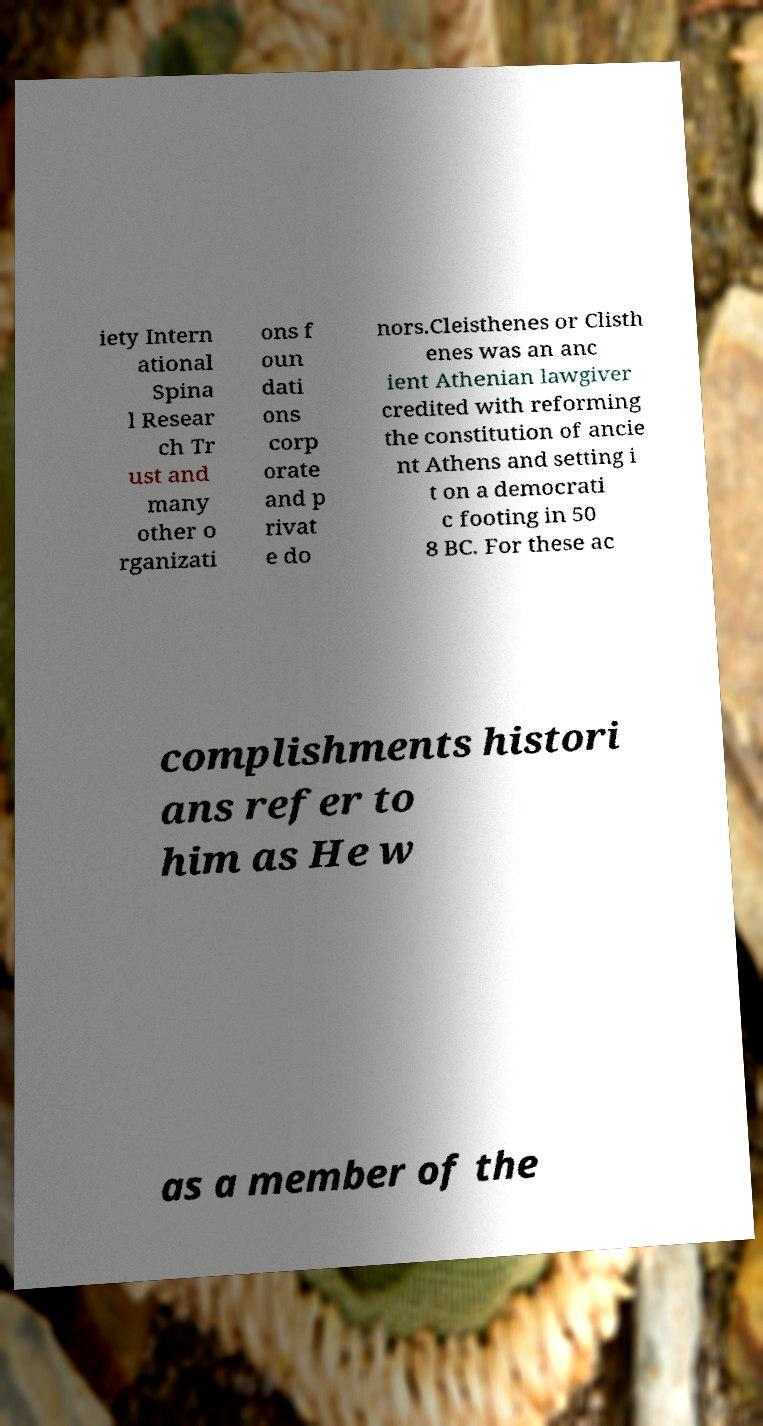Could you extract and type out the text from this image? iety Intern ational Spina l Resear ch Tr ust and many other o rganizati ons f oun dati ons corp orate and p rivat e do nors.Cleisthenes or Clisth enes was an anc ient Athenian lawgiver credited with reforming the constitution of ancie nt Athens and setting i t on a democrati c footing in 50 8 BC. For these ac complishments histori ans refer to him as He w as a member of the 